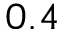Convert formula to latex. <formula><loc_0><loc_0><loc_500><loc_500>0 . 4</formula> 